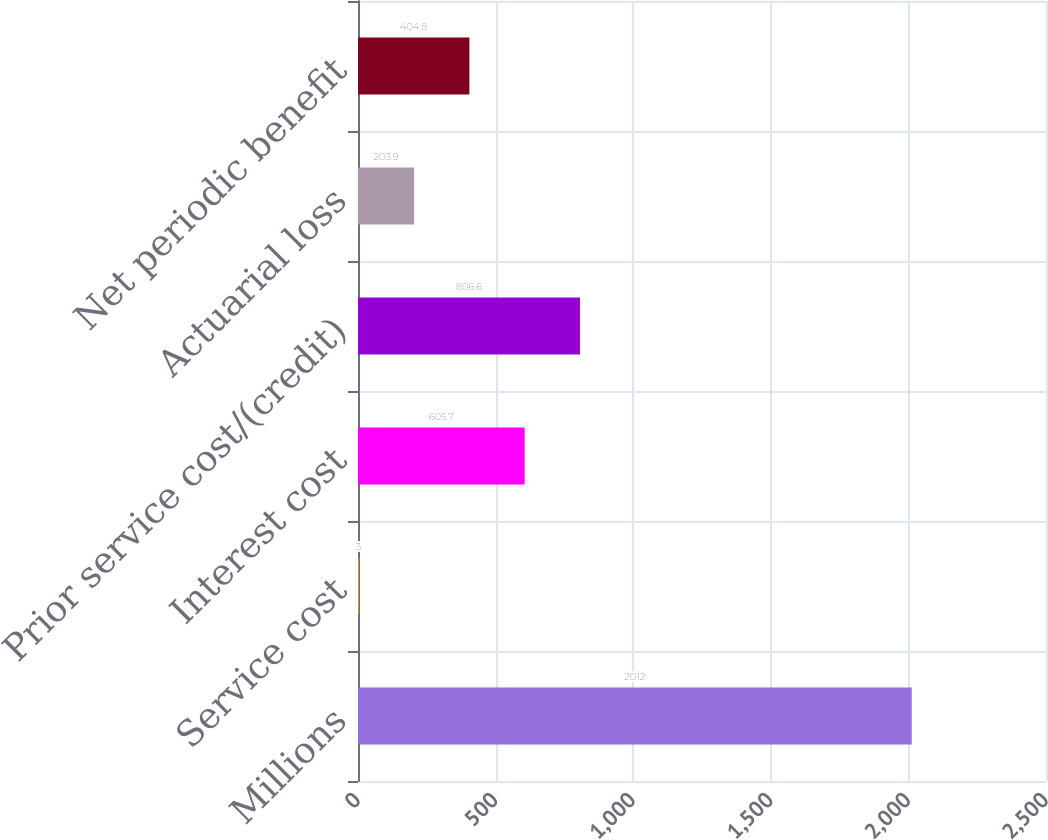Convert chart to OTSL. <chart><loc_0><loc_0><loc_500><loc_500><bar_chart><fcel>Millions<fcel>Service cost<fcel>Interest cost<fcel>Prior service cost/(credit)<fcel>Actuarial loss<fcel>Net periodic benefit<nl><fcel>2012<fcel>3<fcel>605.7<fcel>806.6<fcel>203.9<fcel>404.8<nl></chart> 